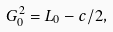Convert formula to latex. <formula><loc_0><loc_0><loc_500><loc_500>G ^ { 2 } _ { 0 } = L _ { 0 } - c / 2 ,</formula> 